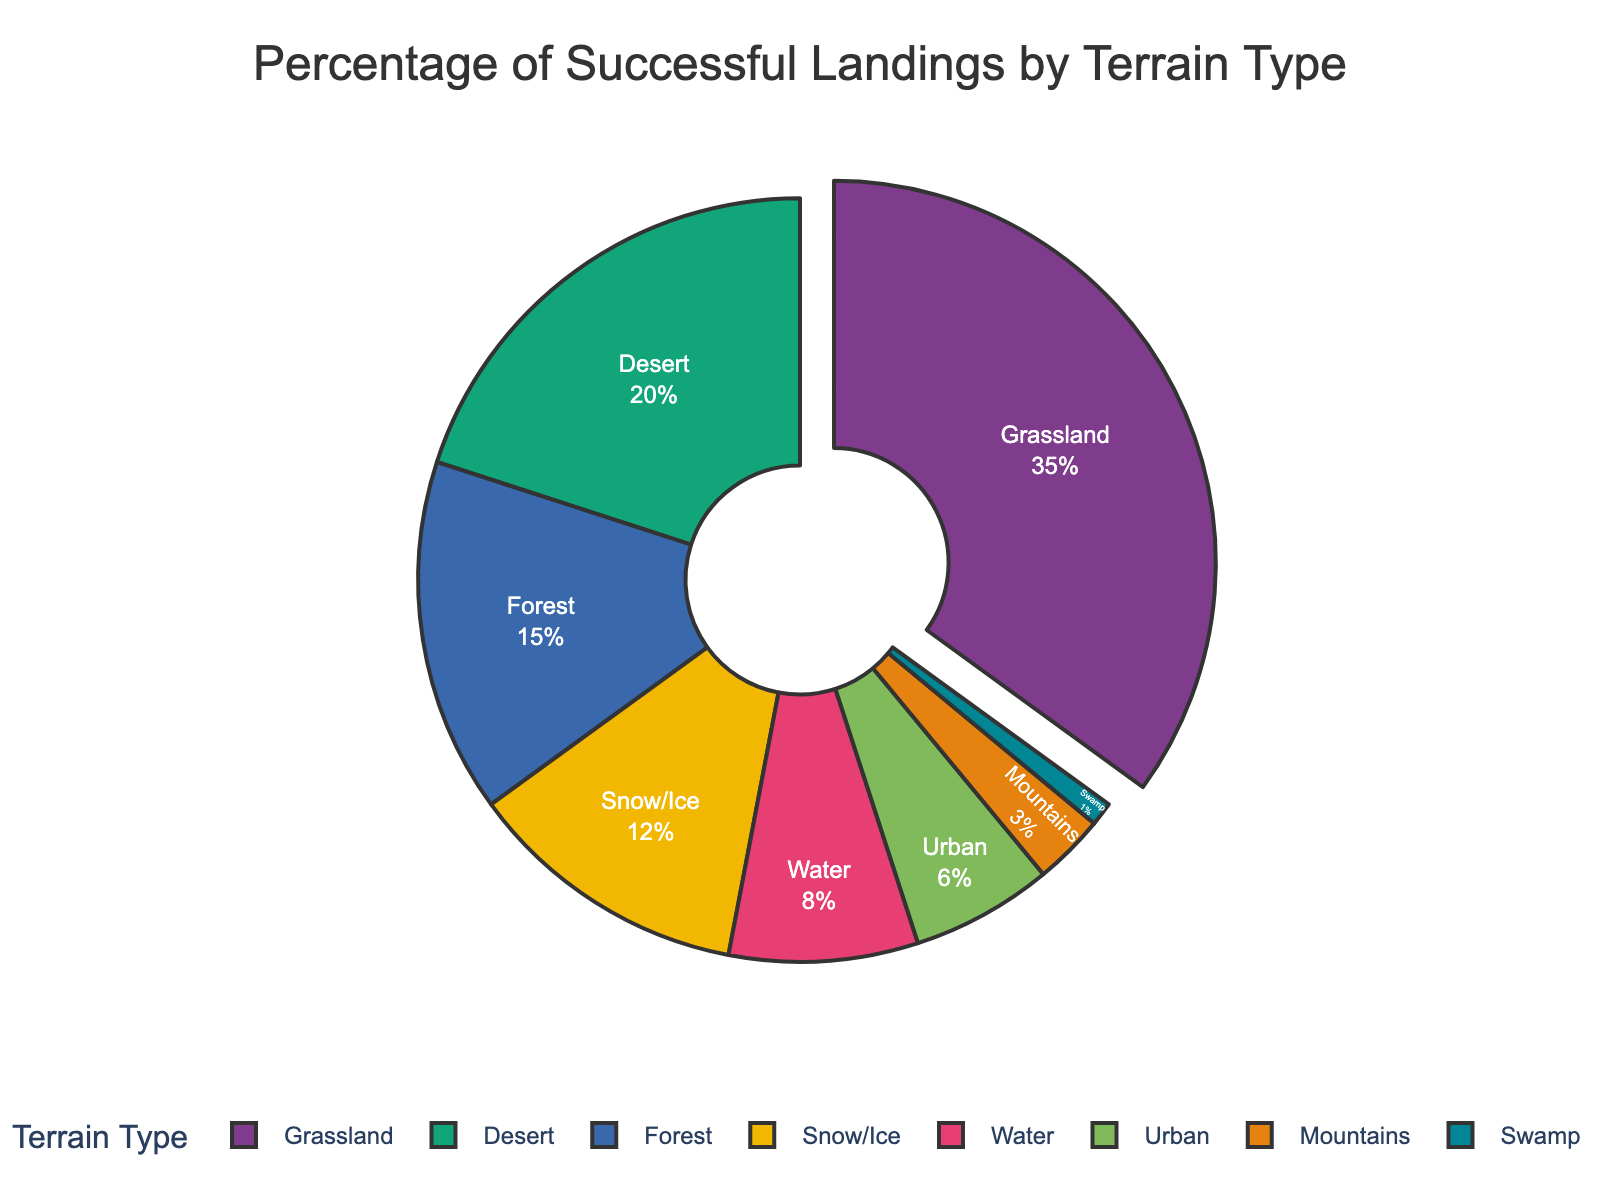Which terrain type has the highest percentage of successful landings? Look for the terrain type with the largest segment in the pie chart labeled with the highest percentage. Here it is Grassland with 35%.
Answer: Grassland Which terrain type has the smallest percentage of successful landings? Look for the terrain type with the smallest segment in the pie chart labeled with the lowest percentage. Here it is Swamp with 1%.
Answer: Swamp What is the total percentage of successful landings in Desert, Forest, and Snow/Ice combined? Add the percentages of Desert (20%), Forest (15%), and Snow/Ice (12%). The sum is 20 + 15 + 12 = 47%.
Answer: 47% How many more percentage points does Grassland have compared to Urban? Subtract the percentage of Urban (6%) from that of Grassland (35%). The difference is 35 - 6 = 29 percentage points.
Answer: 29 What is the combined percentage of the terrain types with successful landings less than 10% each? Add the percentages of Water (8%), Urban (6%), Mountains (3%), and Swamp (1%). The total is 8 + 6 + 3 + 1 = 18%.
Answer: 18% What fraction of successful landings occur in Grassland? The percentage of successful landings in Grassland is 35%. To convert this percentage to a fraction, 35/100 = 7/20.
Answer: 7/20 Which terrain type has more successful landings: Water or Snow/Ice? Compare the percentages of Water (8%) and Snow/Ice (12%). Snow/Ice has more successful landings.
Answer: Snow/Ice How much larger is the Grassland segment compared to the Swamp segment visually? Determine the relative size of the Grassland segment (35%) compared to the Swamp segment (1%). Grassland is 35 times larger.
Answer: 35 times Which terrain types have a combined percentage greater than that of Desert? Compare the sum of selected terrain types to Desert's 20%. Combining Forest (15%) and Snow/Ice (12%) gives 15 + 12 = 27%, which is greater.
Answer: Forest and Snow/Ice How much of the pie chart is represented by Forest and Urban combined? Add the percentages of Forest (15%) and Urban (6%). The sum is 15 + 6 = 21%.
Answer: 21% 